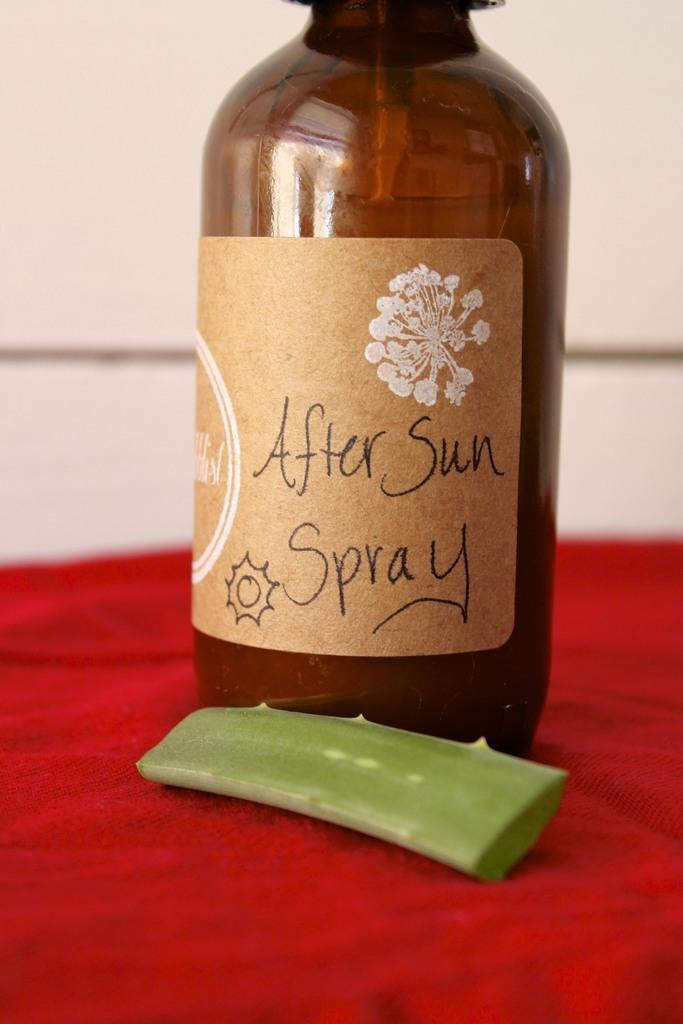How would you summarize this image in a sentence or two? this picture shows a bottle of red color cloth and we see an aloe vera stem 